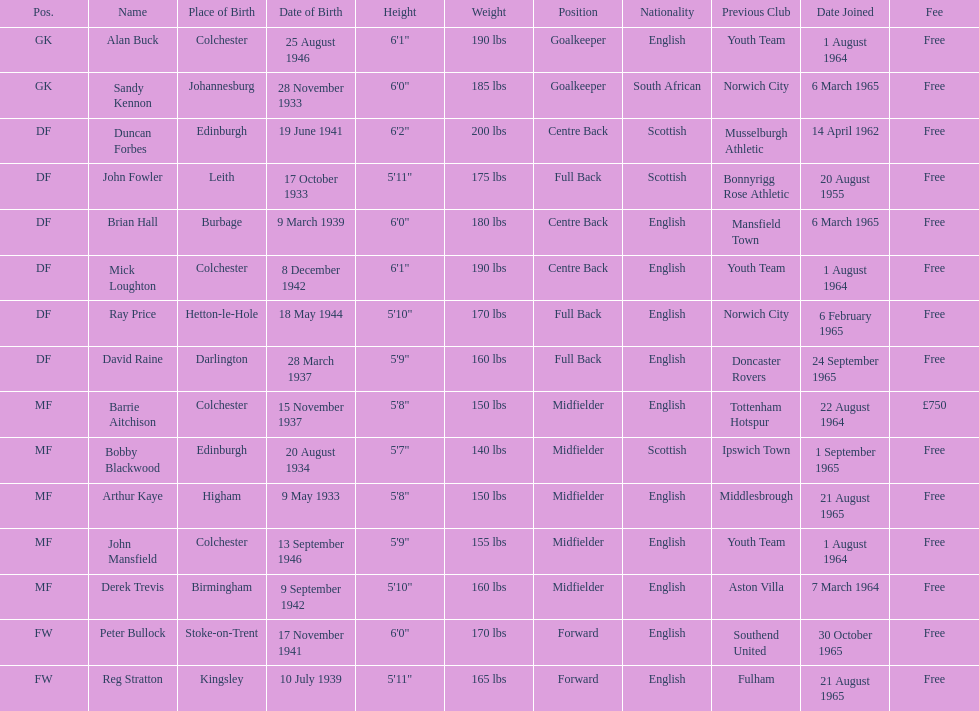Which team was ray price on before he started for this team? Norwich City. Can you parse all the data within this table? {'header': ['Pos.', 'Name', 'Place of Birth', 'Date of Birth', 'Height', 'Weight', 'Position', 'Nationality', 'Previous Club', 'Date Joined', 'Fee'], 'rows': [['GK', 'Alan Buck', 'Colchester', '25 August 1946', '6\'1"', '190 lbs', 'Goalkeeper', 'English', 'Youth Team', '1 August 1964', 'Free'], ['GK', 'Sandy Kennon', 'Johannesburg', '28 November 1933', '6\'0"', '185 lbs', 'Goalkeeper', 'South African', 'Norwich City', '6 March 1965', 'Free'], ['DF', 'Duncan Forbes', 'Edinburgh', '19 June 1941', '6\'2"', '200 lbs', 'Centre Back', 'Scottish', 'Musselburgh Athletic', '14 April 1962', 'Free'], ['DF', 'John Fowler', 'Leith', '17 October 1933', '5\'11"', '175 lbs', 'Full Back', 'Scottish', 'Bonnyrigg Rose Athletic', '20 August 1955', 'Free'], ['DF', 'Brian Hall', 'Burbage', '9 March 1939', '6\'0"', '180 lbs', 'Centre Back', 'English', 'Mansfield Town', '6 March 1965', 'Free'], ['DF', 'Mick Loughton', 'Colchester', '8 December 1942', '6\'1"', '190 lbs', 'Centre Back', 'English', 'Youth Team', '1 August 1964', 'Free'], ['DF', 'Ray Price', 'Hetton-le-Hole', '18 May 1944', '5\'10"', '170 lbs', 'Full Back', 'English', 'Norwich City', '6 February 1965', 'Free'], ['DF', 'David Raine', 'Darlington', '28 March 1937', '5\'9"', '160 lbs', 'Full Back', 'English', 'Doncaster Rovers', '24 September 1965', 'Free'], ['MF', 'Barrie Aitchison', 'Colchester', '15 November 1937', '5\'8"', '150 lbs', 'Midfielder', 'English', 'Tottenham Hotspur', '22 August 1964', '£750'], ['MF', 'Bobby Blackwood', 'Edinburgh', '20 August 1934', '5\'7"', '140 lbs', 'Midfielder', 'Scottish', 'Ipswich Town', '1 September 1965', 'Free'], ['MF', 'Arthur Kaye', 'Higham', '9 May 1933', '5\'8"', '150 lbs', 'Midfielder', 'English', 'Middlesbrough', '21 August 1965', 'Free'], ['MF', 'John Mansfield', 'Colchester', '13 September 1946', '5\'9"', '155 lbs', 'Midfielder', 'English', 'Youth Team', '1 August 1964', 'Free'], ['MF', 'Derek Trevis', 'Birmingham', '9 September 1942', '5\'10"', '160 lbs', 'Midfielder', 'English', 'Aston Villa', '7 March 1964', 'Free'], ['FW', 'Peter Bullock', 'Stoke-on-Trent', '17 November 1941', '6\'0"', '170 lbs', 'Forward', 'English', 'Southend United', '30 October 1965', 'Free'], ['FW', 'Reg Stratton', 'Kingsley', '10 July 1939', '5\'11"', '165 lbs', 'Forward', 'English', 'Fulham', '21 August 1965', 'Free']]} 